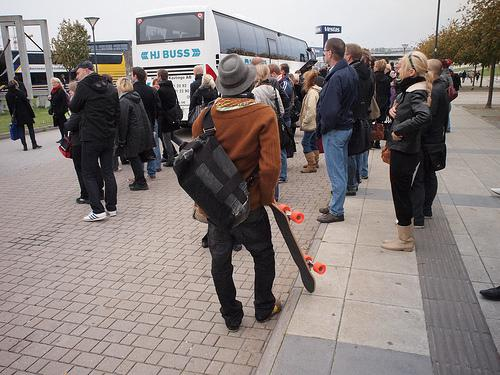Question: who is present?
Choices:
A. Two men.
B. People.
C. Five men.
D. A woman and a man.
Answer with the letter. Answer: B Question: what is present?
Choices:
A. A train.
B. A car.
C. A plane.
D. A bus.
Answer with the letter. Answer: D Question: what are they doing?
Choices:
A. Standing.
B. Running.
C. Walking.
D. Sitting.
Answer with the letter. Answer: A Question: where was this photo taken?
Choices:
A. On the street.
B. In a house.
C. At the beach.
D. In the forest.
Answer with the letter. Answer: A Question: why are they standing?
Choices:
A. To watch the concert.
B. To obey the traffic signal.
C. To board the bus.
D. To see the sunset.
Answer with the letter. Answer: C 